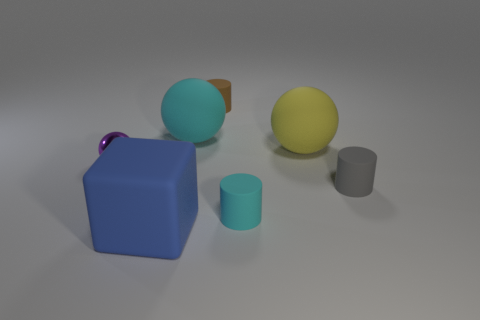Subtract all blue balls. Subtract all cyan cubes. How many balls are left? 3 Add 2 spheres. How many objects exist? 9 Subtract all cylinders. How many objects are left? 4 Add 4 cyan objects. How many cyan objects exist? 6 Subtract 0 red spheres. How many objects are left? 7 Subtract all tiny blue cubes. Subtract all yellow objects. How many objects are left? 6 Add 2 small shiny things. How many small shiny things are left? 3 